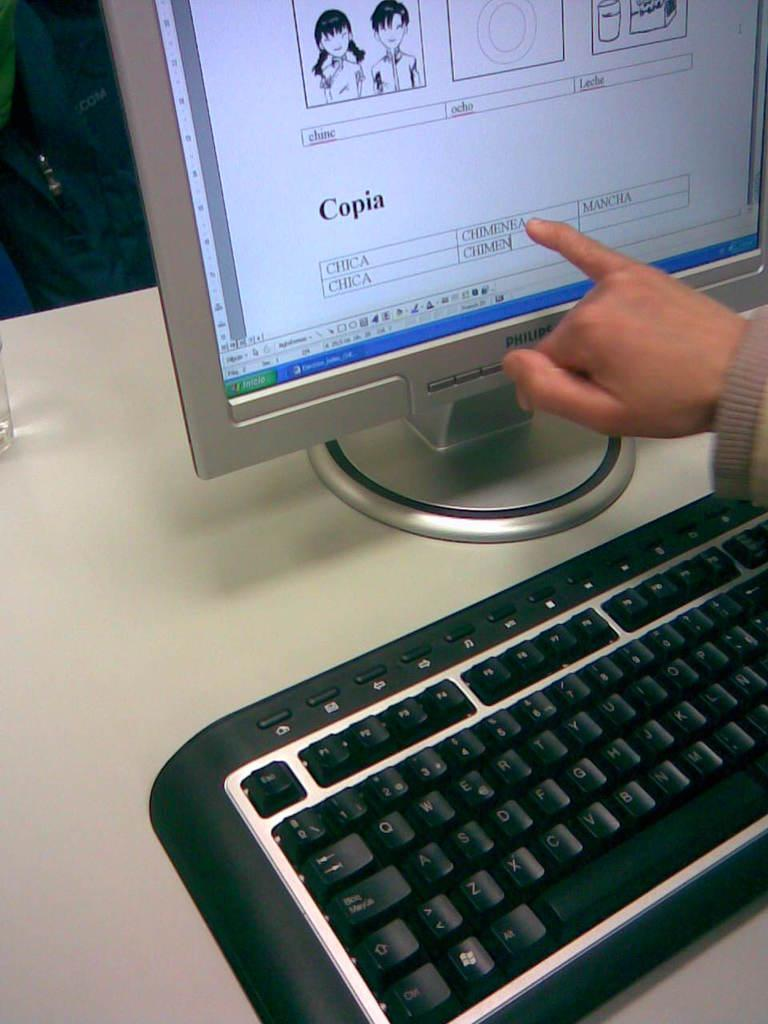<image>
Summarize the visual content of the image. A computer monitor that reads Copia on the text 